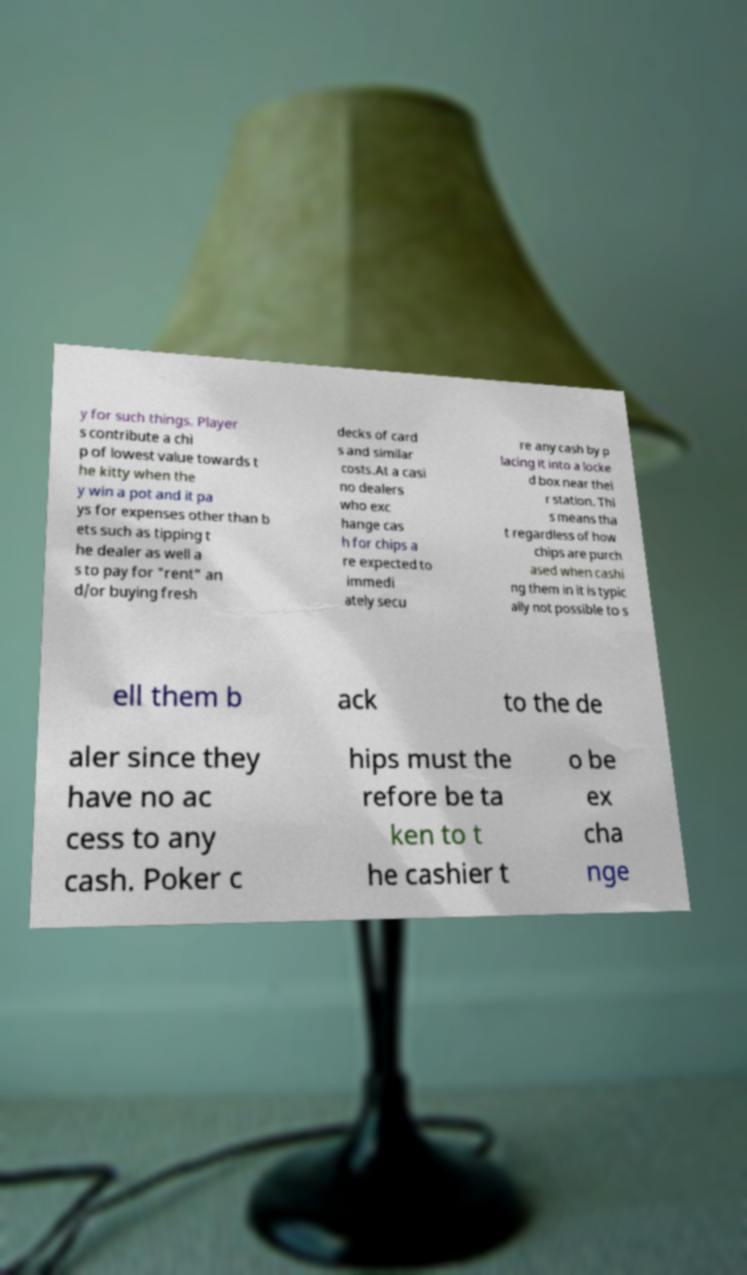What messages or text are displayed in this image? I need them in a readable, typed format. y for such things. Player s contribute a chi p of lowest value towards t he kitty when the y win a pot and it pa ys for expenses other than b ets such as tipping t he dealer as well a s to pay for "rent" an d/or buying fresh decks of card s and similar costs.At a casi no dealers who exc hange cas h for chips a re expected to immedi ately secu re any cash by p lacing it into a locke d box near thei r station. Thi s means tha t regardless of how chips are purch ased when cashi ng them in it is typic ally not possible to s ell them b ack to the de aler since they have no ac cess to any cash. Poker c hips must the refore be ta ken to t he cashier t o be ex cha nge 